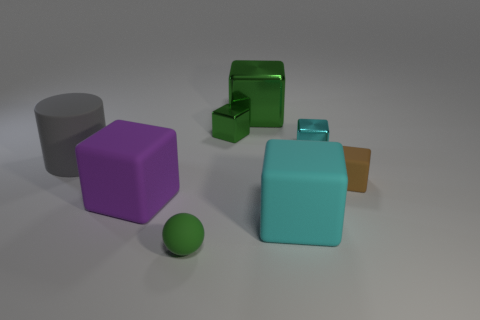There is a big block that is the same color as the tiny rubber ball; what is it made of?
Provide a succinct answer. Metal. There is a cyan object that is behind the small rubber cube; is its shape the same as the large matte thing right of the tiny matte ball?
Your answer should be very brief. Yes. There is a shiny object that is the same color as the large shiny block; what is its shape?
Ensure brevity in your answer.  Cube. What number of tiny brown blocks have the same material as the big cylinder?
Provide a succinct answer. 1. What shape is the object that is right of the big green metallic cube and in front of the small brown matte block?
Keep it short and to the point. Cube. Is the green thing in front of the big cyan cube made of the same material as the large cyan thing?
Your response must be concise. Yes. Is there any other thing that is the same material as the big green thing?
Keep it short and to the point. Yes. The rubber sphere that is the same size as the brown block is what color?
Provide a succinct answer. Green. Is there a matte block of the same color as the small sphere?
Offer a very short reply. No. What size is the cyan cube that is the same material as the large green thing?
Ensure brevity in your answer.  Small. 